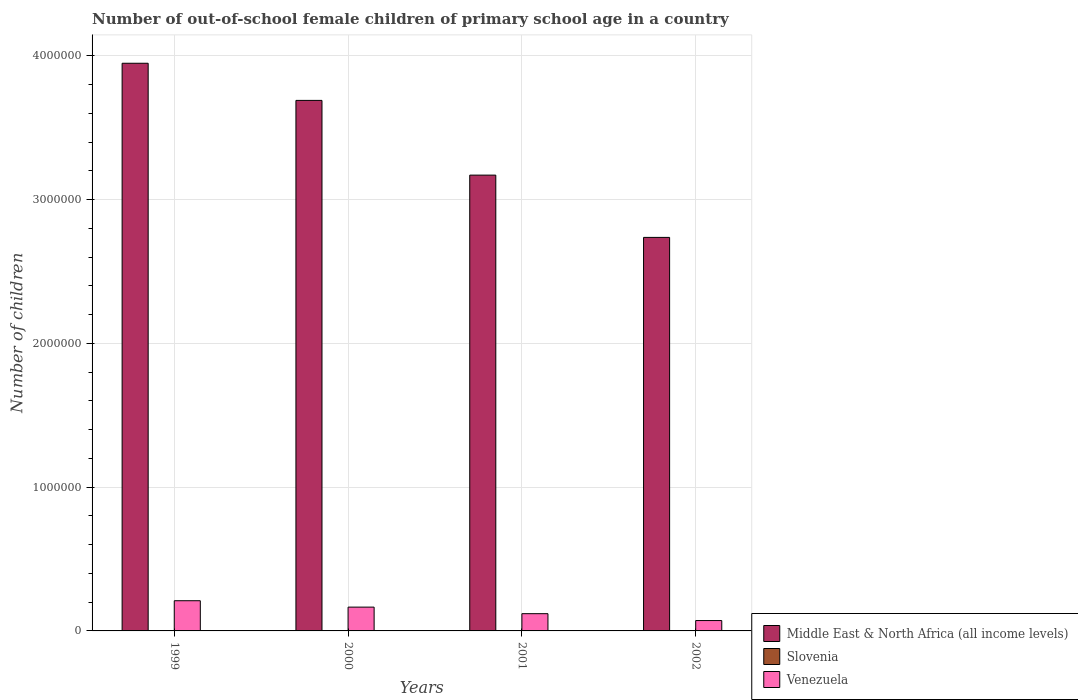How many different coloured bars are there?
Provide a succinct answer. 3. How many groups of bars are there?
Offer a very short reply. 4. How many bars are there on the 3rd tick from the right?
Provide a succinct answer. 3. What is the label of the 2nd group of bars from the left?
Your answer should be compact. 2000. What is the number of out-of-school female children in Venezuela in 2002?
Ensure brevity in your answer.  7.21e+04. Across all years, what is the maximum number of out-of-school female children in Slovenia?
Keep it short and to the point. 1919. Across all years, what is the minimum number of out-of-school female children in Venezuela?
Make the answer very short. 7.21e+04. What is the total number of out-of-school female children in Venezuela in the graph?
Make the answer very short. 5.68e+05. What is the difference between the number of out-of-school female children in Venezuela in 2001 and the number of out-of-school female children in Middle East & North Africa (all income levels) in 2002?
Provide a short and direct response. -2.62e+06. What is the average number of out-of-school female children in Venezuela per year?
Offer a terse response. 1.42e+05. In the year 2000, what is the difference between the number of out-of-school female children in Middle East & North Africa (all income levels) and number of out-of-school female children in Slovenia?
Your answer should be very brief. 3.69e+06. What is the ratio of the number of out-of-school female children in Middle East & North Africa (all income levels) in 1999 to that in 2000?
Ensure brevity in your answer.  1.07. Is the number of out-of-school female children in Venezuela in 1999 less than that in 2001?
Keep it short and to the point. No. Is the difference between the number of out-of-school female children in Middle East & North Africa (all income levels) in 2001 and 2002 greater than the difference between the number of out-of-school female children in Slovenia in 2001 and 2002?
Give a very brief answer. Yes. What is the difference between the highest and the second highest number of out-of-school female children in Venezuela?
Your answer should be very brief. 4.45e+04. What is the difference between the highest and the lowest number of out-of-school female children in Middle East & North Africa (all income levels)?
Provide a short and direct response. 1.21e+06. In how many years, is the number of out-of-school female children in Venezuela greater than the average number of out-of-school female children in Venezuela taken over all years?
Keep it short and to the point. 2. Is the sum of the number of out-of-school female children in Slovenia in 2000 and 2002 greater than the maximum number of out-of-school female children in Middle East & North Africa (all income levels) across all years?
Provide a short and direct response. No. What does the 2nd bar from the left in 2001 represents?
Your answer should be compact. Slovenia. What does the 3rd bar from the right in 2000 represents?
Make the answer very short. Middle East & North Africa (all income levels). Is it the case that in every year, the sum of the number of out-of-school female children in Venezuela and number of out-of-school female children in Slovenia is greater than the number of out-of-school female children in Middle East & North Africa (all income levels)?
Provide a succinct answer. No. How many bars are there?
Provide a short and direct response. 12. Are all the bars in the graph horizontal?
Provide a short and direct response. No. Are the values on the major ticks of Y-axis written in scientific E-notation?
Your answer should be compact. No. Does the graph contain any zero values?
Offer a very short reply. No. Does the graph contain grids?
Your answer should be very brief. Yes. Where does the legend appear in the graph?
Give a very brief answer. Bottom right. How are the legend labels stacked?
Give a very brief answer. Vertical. What is the title of the graph?
Offer a terse response. Number of out-of-school female children of primary school age in a country. Does "Vietnam" appear as one of the legend labels in the graph?
Make the answer very short. No. What is the label or title of the Y-axis?
Keep it short and to the point. Number of children. What is the Number of children in Middle East & North Africa (all income levels) in 1999?
Ensure brevity in your answer.  3.95e+06. What is the Number of children of Slovenia in 1999?
Give a very brief answer. 1755. What is the Number of children in Venezuela in 1999?
Offer a terse response. 2.10e+05. What is the Number of children of Middle East & North Africa (all income levels) in 2000?
Provide a succinct answer. 3.69e+06. What is the Number of children in Slovenia in 2000?
Make the answer very short. 1602. What is the Number of children in Venezuela in 2000?
Make the answer very short. 1.66e+05. What is the Number of children in Middle East & North Africa (all income levels) in 2001?
Provide a short and direct response. 3.17e+06. What is the Number of children in Slovenia in 2001?
Provide a succinct answer. 1919. What is the Number of children of Venezuela in 2001?
Your answer should be compact. 1.20e+05. What is the Number of children of Middle East & North Africa (all income levels) in 2002?
Your answer should be very brief. 2.74e+06. What is the Number of children in Slovenia in 2002?
Ensure brevity in your answer.  1607. What is the Number of children of Venezuela in 2002?
Make the answer very short. 7.21e+04. Across all years, what is the maximum Number of children of Middle East & North Africa (all income levels)?
Provide a short and direct response. 3.95e+06. Across all years, what is the maximum Number of children of Slovenia?
Make the answer very short. 1919. Across all years, what is the maximum Number of children in Venezuela?
Offer a terse response. 2.10e+05. Across all years, what is the minimum Number of children in Middle East & North Africa (all income levels)?
Offer a terse response. 2.74e+06. Across all years, what is the minimum Number of children in Slovenia?
Your answer should be very brief. 1602. Across all years, what is the minimum Number of children of Venezuela?
Keep it short and to the point. 7.21e+04. What is the total Number of children of Middle East & North Africa (all income levels) in the graph?
Provide a short and direct response. 1.35e+07. What is the total Number of children in Slovenia in the graph?
Your answer should be very brief. 6883. What is the total Number of children of Venezuela in the graph?
Offer a very short reply. 5.68e+05. What is the difference between the Number of children in Middle East & North Africa (all income levels) in 1999 and that in 2000?
Ensure brevity in your answer.  2.58e+05. What is the difference between the Number of children in Slovenia in 1999 and that in 2000?
Your response must be concise. 153. What is the difference between the Number of children of Venezuela in 1999 and that in 2000?
Provide a succinct answer. 4.45e+04. What is the difference between the Number of children of Middle East & North Africa (all income levels) in 1999 and that in 2001?
Give a very brief answer. 7.78e+05. What is the difference between the Number of children of Slovenia in 1999 and that in 2001?
Your response must be concise. -164. What is the difference between the Number of children of Venezuela in 1999 and that in 2001?
Provide a short and direct response. 9.01e+04. What is the difference between the Number of children in Middle East & North Africa (all income levels) in 1999 and that in 2002?
Keep it short and to the point. 1.21e+06. What is the difference between the Number of children in Slovenia in 1999 and that in 2002?
Ensure brevity in your answer.  148. What is the difference between the Number of children of Venezuela in 1999 and that in 2002?
Your answer should be very brief. 1.38e+05. What is the difference between the Number of children in Middle East & North Africa (all income levels) in 2000 and that in 2001?
Your answer should be compact. 5.20e+05. What is the difference between the Number of children of Slovenia in 2000 and that in 2001?
Your response must be concise. -317. What is the difference between the Number of children of Venezuela in 2000 and that in 2001?
Keep it short and to the point. 4.56e+04. What is the difference between the Number of children in Middle East & North Africa (all income levels) in 2000 and that in 2002?
Ensure brevity in your answer.  9.53e+05. What is the difference between the Number of children in Venezuela in 2000 and that in 2002?
Offer a very short reply. 9.35e+04. What is the difference between the Number of children of Middle East & North Africa (all income levels) in 2001 and that in 2002?
Your response must be concise. 4.33e+05. What is the difference between the Number of children of Slovenia in 2001 and that in 2002?
Provide a succinct answer. 312. What is the difference between the Number of children of Venezuela in 2001 and that in 2002?
Your response must be concise. 4.79e+04. What is the difference between the Number of children of Middle East & North Africa (all income levels) in 1999 and the Number of children of Slovenia in 2000?
Offer a very short reply. 3.95e+06. What is the difference between the Number of children of Middle East & North Africa (all income levels) in 1999 and the Number of children of Venezuela in 2000?
Keep it short and to the point. 3.78e+06. What is the difference between the Number of children in Slovenia in 1999 and the Number of children in Venezuela in 2000?
Provide a succinct answer. -1.64e+05. What is the difference between the Number of children of Middle East & North Africa (all income levels) in 1999 and the Number of children of Slovenia in 2001?
Offer a terse response. 3.95e+06. What is the difference between the Number of children in Middle East & North Africa (all income levels) in 1999 and the Number of children in Venezuela in 2001?
Provide a short and direct response. 3.83e+06. What is the difference between the Number of children of Slovenia in 1999 and the Number of children of Venezuela in 2001?
Provide a short and direct response. -1.18e+05. What is the difference between the Number of children of Middle East & North Africa (all income levels) in 1999 and the Number of children of Slovenia in 2002?
Give a very brief answer. 3.95e+06. What is the difference between the Number of children of Middle East & North Africa (all income levels) in 1999 and the Number of children of Venezuela in 2002?
Your response must be concise. 3.88e+06. What is the difference between the Number of children of Slovenia in 1999 and the Number of children of Venezuela in 2002?
Your answer should be compact. -7.03e+04. What is the difference between the Number of children in Middle East & North Africa (all income levels) in 2000 and the Number of children in Slovenia in 2001?
Provide a short and direct response. 3.69e+06. What is the difference between the Number of children of Middle East & North Africa (all income levels) in 2000 and the Number of children of Venezuela in 2001?
Your answer should be very brief. 3.57e+06. What is the difference between the Number of children of Slovenia in 2000 and the Number of children of Venezuela in 2001?
Provide a succinct answer. -1.18e+05. What is the difference between the Number of children of Middle East & North Africa (all income levels) in 2000 and the Number of children of Slovenia in 2002?
Offer a terse response. 3.69e+06. What is the difference between the Number of children in Middle East & North Africa (all income levels) in 2000 and the Number of children in Venezuela in 2002?
Your answer should be compact. 3.62e+06. What is the difference between the Number of children of Slovenia in 2000 and the Number of children of Venezuela in 2002?
Offer a terse response. -7.05e+04. What is the difference between the Number of children of Middle East & North Africa (all income levels) in 2001 and the Number of children of Slovenia in 2002?
Give a very brief answer. 3.17e+06. What is the difference between the Number of children of Middle East & North Africa (all income levels) in 2001 and the Number of children of Venezuela in 2002?
Make the answer very short. 3.10e+06. What is the difference between the Number of children of Slovenia in 2001 and the Number of children of Venezuela in 2002?
Provide a succinct answer. -7.02e+04. What is the average Number of children of Middle East & North Africa (all income levels) per year?
Your answer should be compact. 3.39e+06. What is the average Number of children of Slovenia per year?
Provide a succinct answer. 1720.75. What is the average Number of children in Venezuela per year?
Give a very brief answer. 1.42e+05. In the year 1999, what is the difference between the Number of children in Middle East & North Africa (all income levels) and Number of children in Slovenia?
Provide a short and direct response. 3.95e+06. In the year 1999, what is the difference between the Number of children in Middle East & North Africa (all income levels) and Number of children in Venezuela?
Offer a very short reply. 3.74e+06. In the year 1999, what is the difference between the Number of children in Slovenia and Number of children in Venezuela?
Provide a short and direct response. -2.08e+05. In the year 2000, what is the difference between the Number of children of Middle East & North Africa (all income levels) and Number of children of Slovenia?
Your answer should be very brief. 3.69e+06. In the year 2000, what is the difference between the Number of children of Middle East & North Africa (all income levels) and Number of children of Venezuela?
Your answer should be very brief. 3.53e+06. In the year 2000, what is the difference between the Number of children in Slovenia and Number of children in Venezuela?
Make the answer very short. -1.64e+05. In the year 2001, what is the difference between the Number of children of Middle East & North Africa (all income levels) and Number of children of Slovenia?
Keep it short and to the point. 3.17e+06. In the year 2001, what is the difference between the Number of children of Middle East & North Africa (all income levels) and Number of children of Venezuela?
Keep it short and to the point. 3.05e+06. In the year 2001, what is the difference between the Number of children of Slovenia and Number of children of Venezuela?
Provide a short and direct response. -1.18e+05. In the year 2002, what is the difference between the Number of children in Middle East & North Africa (all income levels) and Number of children in Slovenia?
Keep it short and to the point. 2.74e+06. In the year 2002, what is the difference between the Number of children in Middle East & North Africa (all income levels) and Number of children in Venezuela?
Your response must be concise. 2.67e+06. In the year 2002, what is the difference between the Number of children in Slovenia and Number of children in Venezuela?
Provide a short and direct response. -7.05e+04. What is the ratio of the Number of children of Middle East & North Africa (all income levels) in 1999 to that in 2000?
Offer a very short reply. 1.07. What is the ratio of the Number of children of Slovenia in 1999 to that in 2000?
Your answer should be very brief. 1.1. What is the ratio of the Number of children of Venezuela in 1999 to that in 2000?
Provide a short and direct response. 1.27. What is the ratio of the Number of children of Middle East & North Africa (all income levels) in 1999 to that in 2001?
Offer a terse response. 1.25. What is the ratio of the Number of children of Slovenia in 1999 to that in 2001?
Make the answer very short. 0.91. What is the ratio of the Number of children of Venezuela in 1999 to that in 2001?
Give a very brief answer. 1.75. What is the ratio of the Number of children of Middle East & North Africa (all income levels) in 1999 to that in 2002?
Your answer should be compact. 1.44. What is the ratio of the Number of children of Slovenia in 1999 to that in 2002?
Your answer should be compact. 1.09. What is the ratio of the Number of children in Venezuela in 1999 to that in 2002?
Make the answer very short. 2.91. What is the ratio of the Number of children of Middle East & North Africa (all income levels) in 2000 to that in 2001?
Keep it short and to the point. 1.16. What is the ratio of the Number of children of Slovenia in 2000 to that in 2001?
Keep it short and to the point. 0.83. What is the ratio of the Number of children of Venezuela in 2000 to that in 2001?
Your answer should be very brief. 1.38. What is the ratio of the Number of children in Middle East & North Africa (all income levels) in 2000 to that in 2002?
Your response must be concise. 1.35. What is the ratio of the Number of children of Venezuela in 2000 to that in 2002?
Your response must be concise. 2.3. What is the ratio of the Number of children in Middle East & North Africa (all income levels) in 2001 to that in 2002?
Your response must be concise. 1.16. What is the ratio of the Number of children of Slovenia in 2001 to that in 2002?
Provide a short and direct response. 1.19. What is the ratio of the Number of children in Venezuela in 2001 to that in 2002?
Make the answer very short. 1.66. What is the difference between the highest and the second highest Number of children in Middle East & North Africa (all income levels)?
Your answer should be compact. 2.58e+05. What is the difference between the highest and the second highest Number of children of Slovenia?
Your answer should be compact. 164. What is the difference between the highest and the second highest Number of children in Venezuela?
Give a very brief answer. 4.45e+04. What is the difference between the highest and the lowest Number of children of Middle East & North Africa (all income levels)?
Your answer should be compact. 1.21e+06. What is the difference between the highest and the lowest Number of children in Slovenia?
Your response must be concise. 317. What is the difference between the highest and the lowest Number of children of Venezuela?
Offer a very short reply. 1.38e+05. 